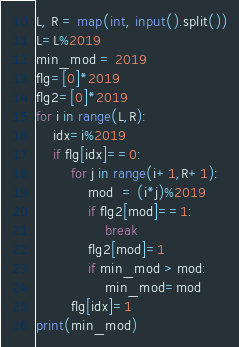<code> <loc_0><loc_0><loc_500><loc_500><_Python_>L, R = map(int, input().split())
L=L%2019
min_mod = 2019
flg=[0]*2019
flg2=[0]*2019
for i in range(L,R):
    idx=i%2019
    if flg[idx]==0:
        for j in range(i+1,R+1):
            mod  = (i*j)%2019
            if flg2[mod]==1:
                break
            flg2[mod]=1
            if min_mod > mod:
                min_mod=mod
        flg[idx]=1
print(min_mod)</code> 